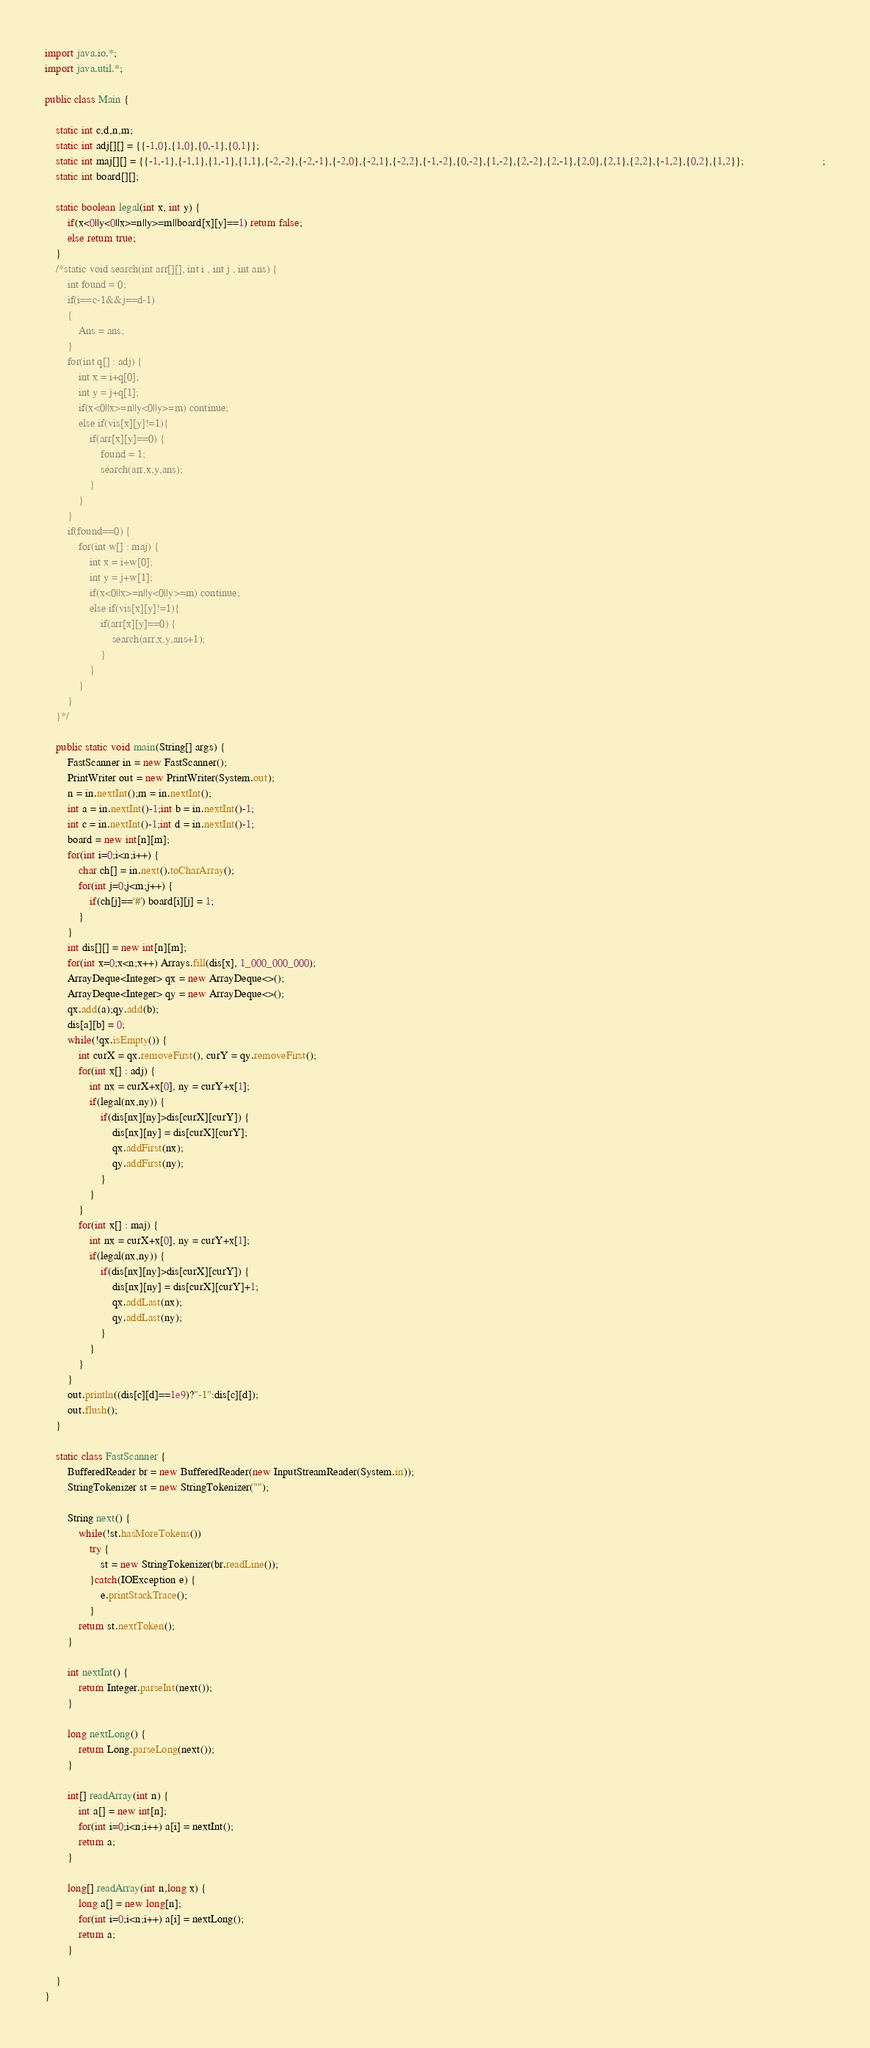Convert code to text. <code><loc_0><loc_0><loc_500><loc_500><_Java_>import java.io.*;
import java.util.*;

public class Main {
	
	static int c,d,n,m;
	static int adj[][] = {{-1,0},{1,0},{0,-1},{0,1}};
	static int maj[][] = {{-1,-1},{-1,1},{1,-1},{1,1},{-2,-2},{-2,-1},{-2,0},{-2,1},{-2,2},{-1,-2},{0,-2},{1,-2},{2,-2},{2,-1},{2,0},{2,1},{2,2},{-1,2},{0,2},{1,2}};                            ;
	static int board[][];
	
	static boolean legal(int x, int y) {
		if(x<0||y<0||x>=n||y>=m||board[x][y]==1) return false;
		else return true;
	}
	/*static void search(int arr[][], int i , int j , int ans) {
		int found = 0;
		if(i==c-1&&j==d-1) 
		{
			Ans = ans;
		}
		for(int q[] : adj) {
			int x = i+q[0];
			int y = j+q[1];
			if(x<0||x>=n||y<0||y>=m) continue;
			else if(vis[x][y]!=1){
				if(arr[x][y]==0) {
					found = 1;
					search(arr,x,y,ans);
				}
			}
		}
		if(found==0) {
			for(int w[] : maj) {
				int x = i+w[0];
				int y = j+w[1];
				if(x<0||x>=n||y<0||y>=m) continue;
				else if(vis[x][y]!=1){
					if(arr[x][y]==0) {
						search(arr,x,y,ans+1);
					}
				}
			}
		}
	}*/
	
	public static void main(String[] args) {
        FastScanner in = new FastScanner();
        PrintWriter out = new PrintWriter(System.out);
        n = in.nextInt();m = in.nextInt();
        int a = in.nextInt()-1;int b = in.nextInt()-1;
        int c = in.nextInt()-1;int d = in.nextInt()-1;
        board = new int[n][m];
        for(int i=0;i<n;i++) {
        	char ch[] = in.next().toCharArray();
        	for(int j=0;j<m;j++) {
        		if(ch[j]=='#') board[i][j] = 1;
        	}
        }
        int dis[][] = new int[n][m];
        for(int x=0;x<n;x++) Arrays.fill(dis[x], 1_000_000_000);
        ArrayDeque<Integer> qx = new ArrayDeque<>();
        ArrayDeque<Integer> qy = new ArrayDeque<>();
        qx.add(a);qy.add(b);
        dis[a][b] = 0;
        while(!qx.isEmpty()) {
        	int curX = qx.removeFirst(), curY = qy.removeFirst();
        	for(int x[] : adj) {
        		int nx = curX+x[0], ny = curY+x[1];
        		if(legal(nx,ny)) {
        			if(dis[nx][ny]>dis[curX][curY]) {
        				dis[nx][ny] = dis[curX][curY];
        				qx.addFirst(nx);
        				qy.addFirst(ny);
        			}
        		}
        	}
        	for(int x[] : maj) {
        		int nx = curX+x[0], ny = curY+x[1];
        		if(legal(nx,ny)) {
        			if(dis[nx][ny]>dis[curX][curY]) {
        				dis[nx][ny] = dis[curX][curY]+1;
        				qx.addLast(nx);
        				qy.addLast(ny);
        			}
        		}
        	}
        }
        out.println((dis[c][d]==1e9)?"-1":dis[c][d]);
        out.flush();
	}
	
	static class FastScanner {
		BufferedReader br = new BufferedReader(new InputStreamReader(System.in));
		StringTokenizer st = new StringTokenizer("");
		
		String next() {
			while(!st.hasMoreTokens())
				try {
					st = new StringTokenizer(br.readLine());
				}catch(IOException e) {
					e.printStackTrace();
				}
			return st.nextToken();
		}
		
		int nextInt() {
			return Integer.parseInt(next());
		}
		
		long nextLong() {
			return Long.parseLong(next());
		}
		
		int[] readArray(int n) {
			int a[] = new int[n];
			for(int i=0;i<n;i++) a[i] = nextInt();
			return a;
		}
		
		long[] readArray(int n,long x) {
			long a[] = new long[n];
			for(int i=0;i<n;i++) a[i] = nextLong();
			return a;
		}
		
	}
}









</code> 